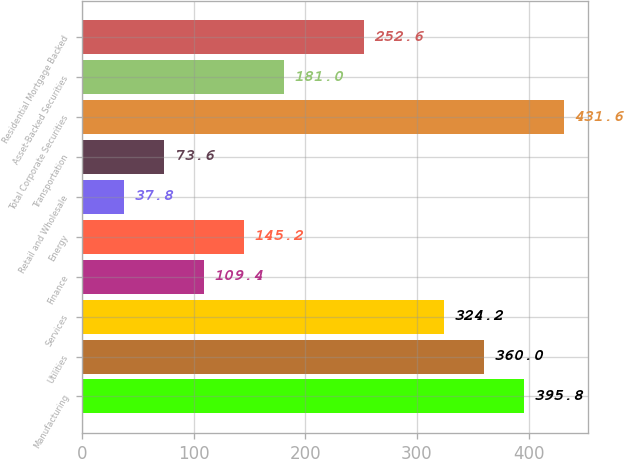Convert chart to OTSL. <chart><loc_0><loc_0><loc_500><loc_500><bar_chart><fcel>Manufacturing<fcel>Utilities<fcel>Services<fcel>Finance<fcel>Energy<fcel>Retail and Wholesale<fcel>Transportation<fcel>Total Corporate Securities<fcel>Asset-Backed Securities<fcel>Residential Mortgage Backed<nl><fcel>395.8<fcel>360<fcel>324.2<fcel>109.4<fcel>145.2<fcel>37.8<fcel>73.6<fcel>431.6<fcel>181<fcel>252.6<nl></chart> 